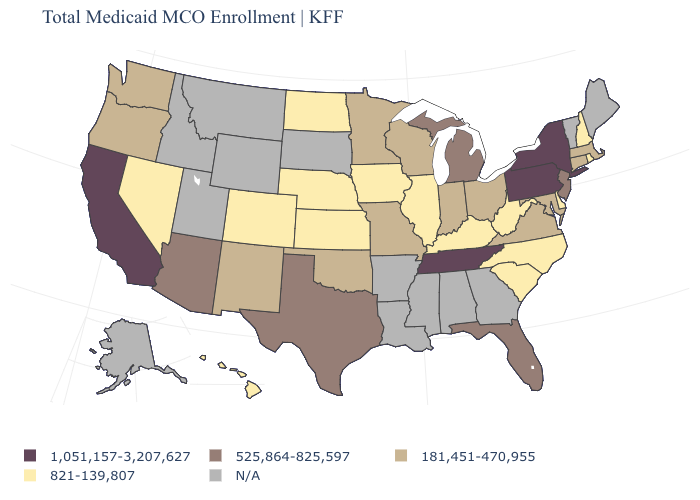Which states have the highest value in the USA?
Short answer required. California, New York, Pennsylvania, Tennessee. Name the states that have a value in the range 525,864-825,597?
Give a very brief answer. Arizona, Florida, Michigan, New Jersey, Texas. Among the states that border Vermont , does New York have the highest value?
Concise answer only. Yes. What is the value of Nevada?
Quick response, please. 821-139,807. Does North Carolina have the lowest value in the USA?
Keep it brief. Yes. Which states have the highest value in the USA?
Keep it brief. California, New York, Pennsylvania, Tennessee. What is the highest value in states that border Texas?
Be succinct. 181,451-470,955. What is the value of Alabama?
Give a very brief answer. N/A. What is the value of Arkansas?
Give a very brief answer. N/A. What is the value of Rhode Island?
Give a very brief answer. 821-139,807. Name the states that have a value in the range 525,864-825,597?
Be succinct. Arizona, Florida, Michigan, New Jersey, Texas. What is the value of Arizona?
Be succinct. 525,864-825,597. Does Connecticut have the lowest value in the Northeast?
Concise answer only. No. Which states have the lowest value in the USA?
Keep it brief. Colorado, Delaware, Hawaii, Illinois, Iowa, Kansas, Kentucky, Nebraska, Nevada, New Hampshire, North Carolina, North Dakota, Rhode Island, South Carolina, West Virginia. 